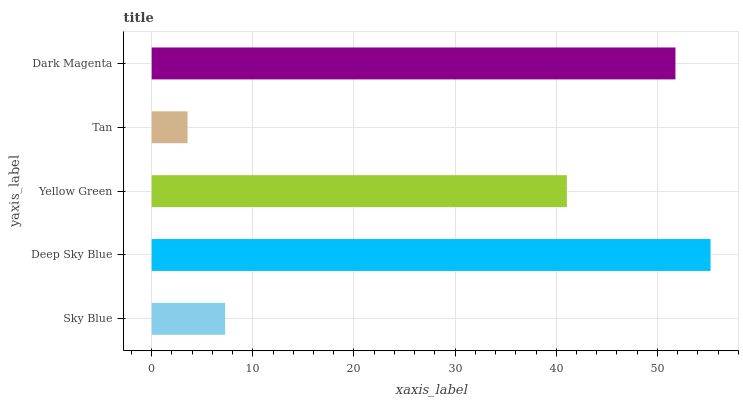Is Tan the minimum?
Answer yes or no. Yes. Is Deep Sky Blue the maximum?
Answer yes or no. Yes. Is Yellow Green the minimum?
Answer yes or no. No. Is Yellow Green the maximum?
Answer yes or no. No. Is Deep Sky Blue greater than Yellow Green?
Answer yes or no. Yes. Is Yellow Green less than Deep Sky Blue?
Answer yes or no. Yes. Is Yellow Green greater than Deep Sky Blue?
Answer yes or no. No. Is Deep Sky Blue less than Yellow Green?
Answer yes or no. No. Is Yellow Green the high median?
Answer yes or no. Yes. Is Yellow Green the low median?
Answer yes or no. Yes. Is Dark Magenta the high median?
Answer yes or no. No. Is Tan the low median?
Answer yes or no. No. 